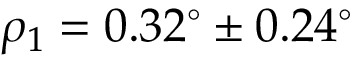Convert formula to latex. <formula><loc_0><loc_0><loc_500><loc_500>\rho _ { 1 } = 0 . 3 2 ^ { \circ } \pm 0 . 2 4 ^ { \circ }</formula> 